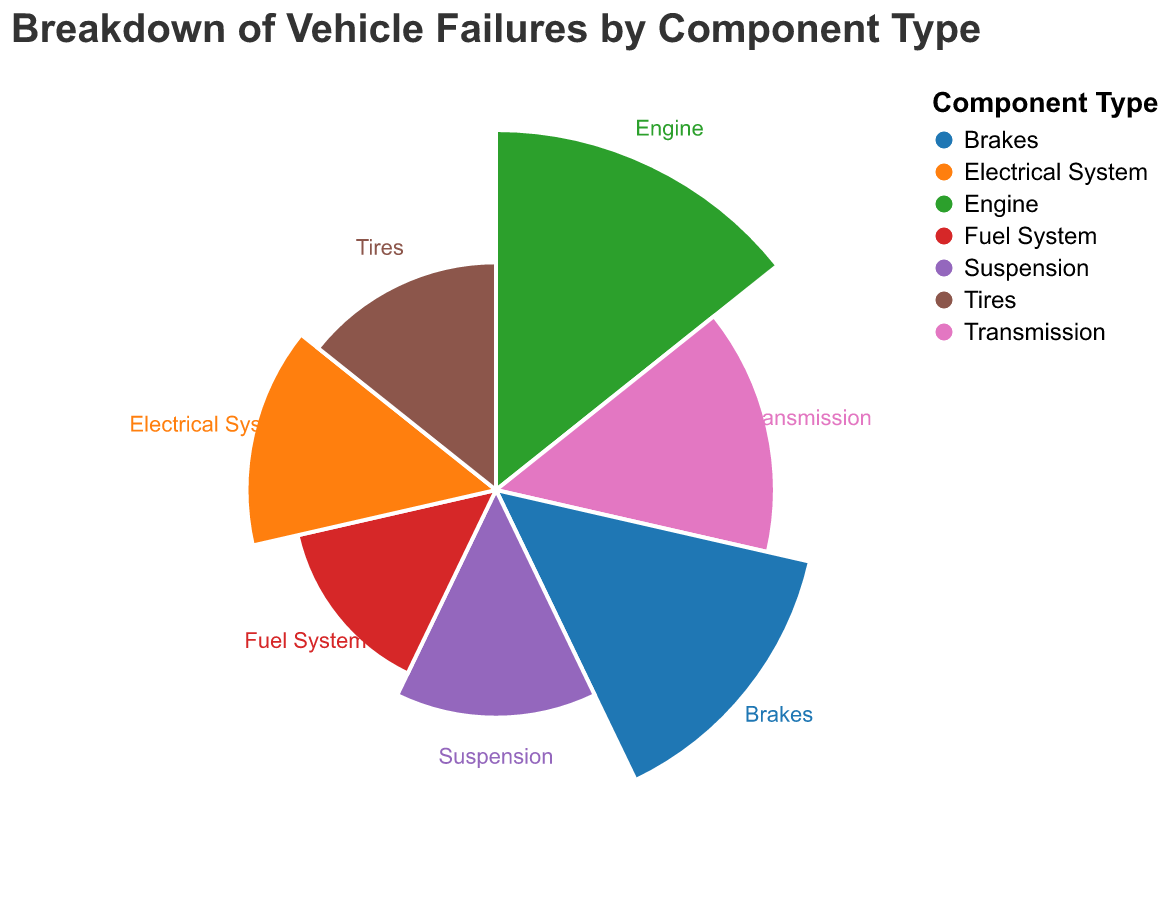What's the title of the figure? The title of the figure is located at the top and is highlighted for easy identification. It generally provides an overview of the chart content.
Answer: Breakdown of Vehicle Failures by Component Type Which component type has the highest percentage of failures? By examining the lengths of the arcs, the component with the longest arc represents the highest percentage of failures.
Answer: Engine What is the percentage contribution of the fuel system to vehicle failures? Locate the segment labeled "Fuel System" on the polar chart and note the percentage value associated with it.
Answer: 8% How does the percentage for brake failures compare to that for tire failures? Identify the segments for "Brakes" and "Tires". Compare the percentage values noted for each, highlighting their differences.
Answer: Brakes (20%) are higher than Tires (10%) What is the combined percentage for suspension and tires? Add the percentages of the suspension and tire segments by finding their respective values on the chart and summing them up.
Answer: 10% + 10% = 20% Which components have exactly the same percentage of failures? Look for segments that have the same lengths and percentage values.
Answer: Suspension and Tires How much more frequent are engine failures compared to fuel system failures? Subtract the percentage of fuel system failures from the percentage of engine failures by finding their respective values on the chart.
Answer: 25% - 8% = 17% What percentage of the total failures is attributed to the transmission and electrical system combined? Add the percentages of the transmission and electrical system segments by finding their respective values on the chart and summing them up.
Answer: 15% + 12% = 27% Which component type is the third most frequent cause of vehicle failures? Order the segments by their percentage values from highest to lowest and identify the third one on the list.
Answer: Brakes (20%) How does the visual representation help to understand the distribution of vehicle failures? The use of a polar chart allows for an immediate visual comparison of component failure rates through the lengths and positions of the arcs, making discrepancies and distributions clear.
Answer: Immediate visual comparison 